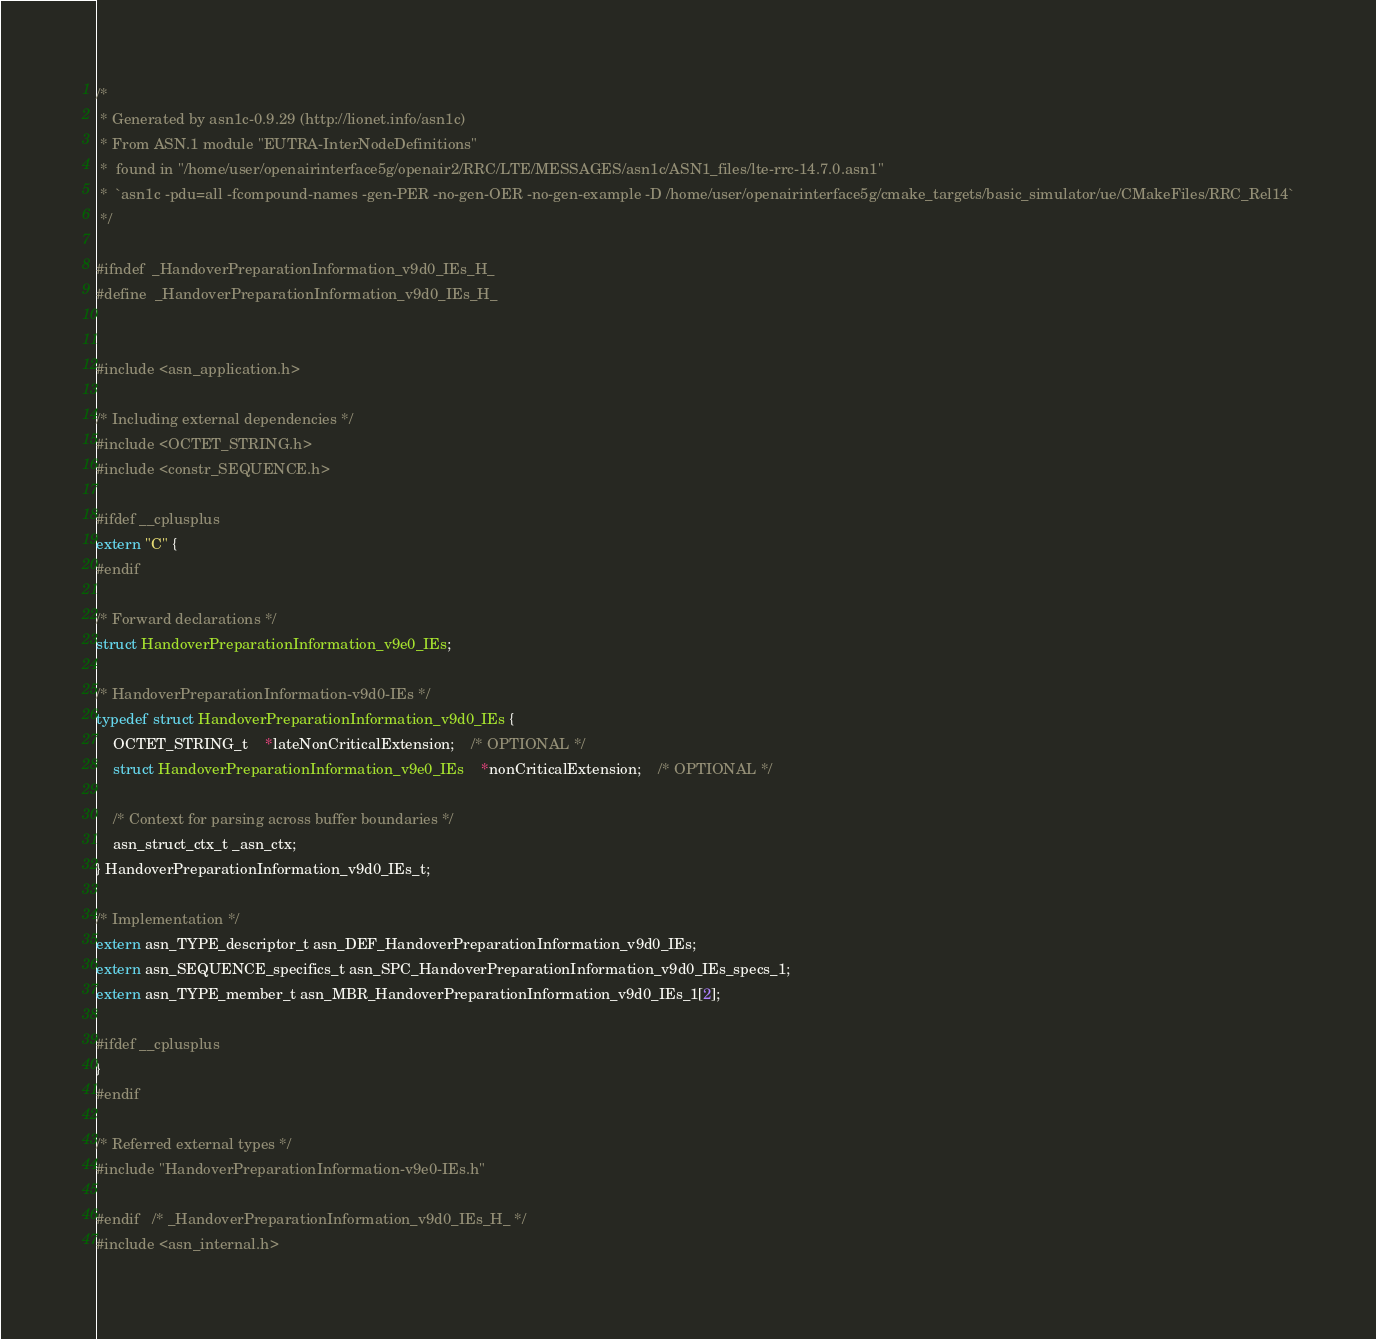Convert code to text. <code><loc_0><loc_0><loc_500><loc_500><_C_>/*
 * Generated by asn1c-0.9.29 (http://lionet.info/asn1c)
 * From ASN.1 module "EUTRA-InterNodeDefinitions"
 * 	found in "/home/user/openairinterface5g/openair2/RRC/LTE/MESSAGES/asn1c/ASN1_files/lte-rrc-14.7.0.asn1"
 * 	`asn1c -pdu=all -fcompound-names -gen-PER -no-gen-OER -no-gen-example -D /home/user/openairinterface5g/cmake_targets/basic_simulator/ue/CMakeFiles/RRC_Rel14`
 */

#ifndef	_HandoverPreparationInformation_v9d0_IEs_H_
#define	_HandoverPreparationInformation_v9d0_IEs_H_


#include <asn_application.h>

/* Including external dependencies */
#include <OCTET_STRING.h>
#include <constr_SEQUENCE.h>

#ifdef __cplusplus
extern "C" {
#endif

/* Forward declarations */
struct HandoverPreparationInformation_v9e0_IEs;

/* HandoverPreparationInformation-v9d0-IEs */
typedef struct HandoverPreparationInformation_v9d0_IEs {
	OCTET_STRING_t	*lateNonCriticalExtension;	/* OPTIONAL */
	struct HandoverPreparationInformation_v9e0_IEs	*nonCriticalExtension;	/* OPTIONAL */
	
	/* Context for parsing across buffer boundaries */
	asn_struct_ctx_t _asn_ctx;
} HandoverPreparationInformation_v9d0_IEs_t;

/* Implementation */
extern asn_TYPE_descriptor_t asn_DEF_HandoverPreparationInformation_v9d0_IEs;
extern asn_SEQUENCE_specifics_t asn_SPC_HandoverPreparationInformation_v9d0_IEs_specs_1;
extern asn_TYPE_member_t asn_MBR_HandoverPreparationInformation_v9d0_IEs_1[2];

#ifdef __cplusplus
}
#endif

/* Referred external types */
#include "HandoverPreparationInformation-v9e0-IEs.h"

#endif	/* _HandoverPreparationInformation_v9d0_IEs_H_ */
#include <asn_internal.h>
</code> 